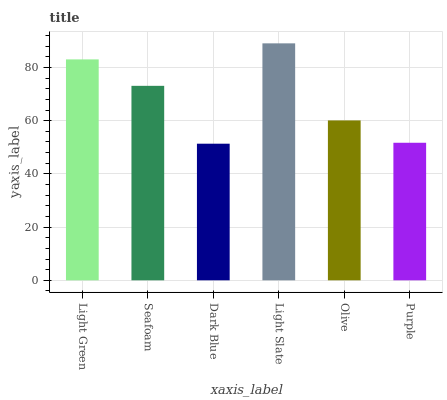Is Dark Blue the minimum?
Answer yes or no. Yes. Is Light Slate the maximum?
Answer yes or no. Yes. Is Seafoam the minimum?
Answer yes or no. No. Is Seafoam the maximum?
Answer yes or no. No. Is Light Green greater than Seafoam?
Answer yes or no. Yes. Is Seafoam less than Light Green?
Answer yes or no. Yes. Is Seafoam greater than Light Green?
Answer yes or no. No. Is Light Green less than Seafoam?
Answer yes or no. No. Is Seafoam the high median?
Answer yes or no. Yes. Is Olive the low median?
Answer yes or no. Yes. Is Light Green the high median?
Answer yes or no. No. Is Light Slate the low median?
Answer yes or no. No. 